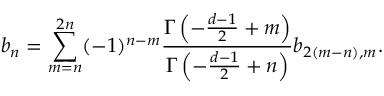<formula> <loc_0><loc_0><loc_500><loc_500>b _ { n } = \sum _ { m = n } ^ { 2 n } ( - 1 ) ^ { n - m } { \frac { \Gamma \left ( - { \frac { d - 1 } { 2 } } + m \right ) } { \Gamma \left ( - { \frac { d - 1 } { 2 } } + n \right ) } } b _ { 2 ( m - n ) , m } .</formula> 